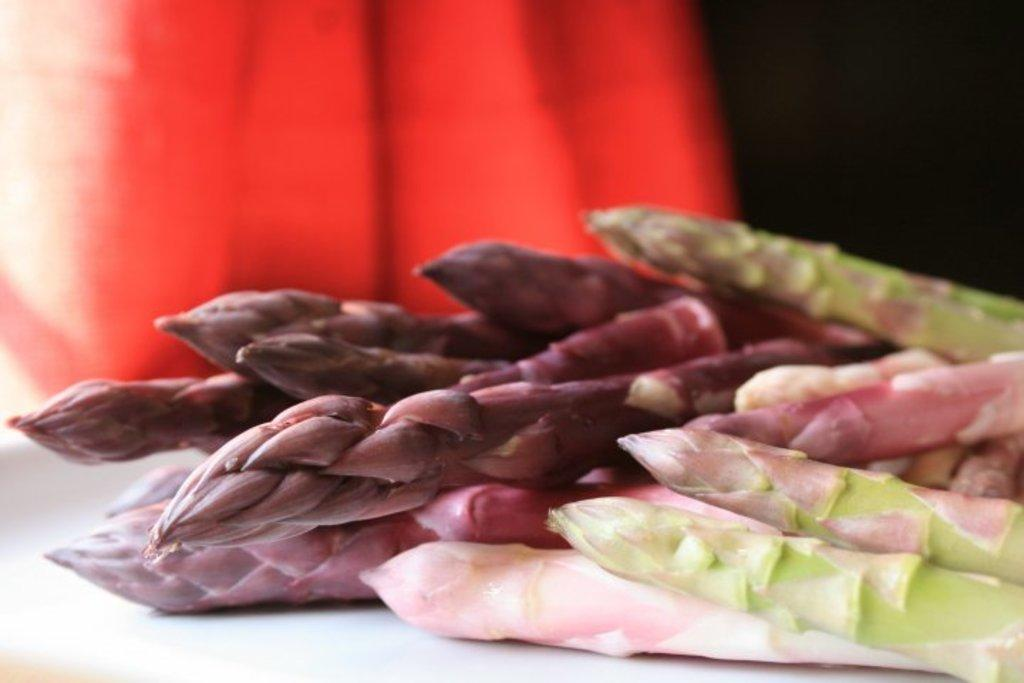What type of flowers are in the image? There are lotus flowers in the image. What else can be seen on the table besides the lotus flowers? There are other stems on the table. Where do you think the image was taken? The image is likely taken in a room. What colors can be seen in the background of the image? The background of the image contains red and black colors. Can you hear the voice of the person who took the picture in the image? There is no audible information in the image, so it is not possible to hear any voice, including that of the person who took the picture. 